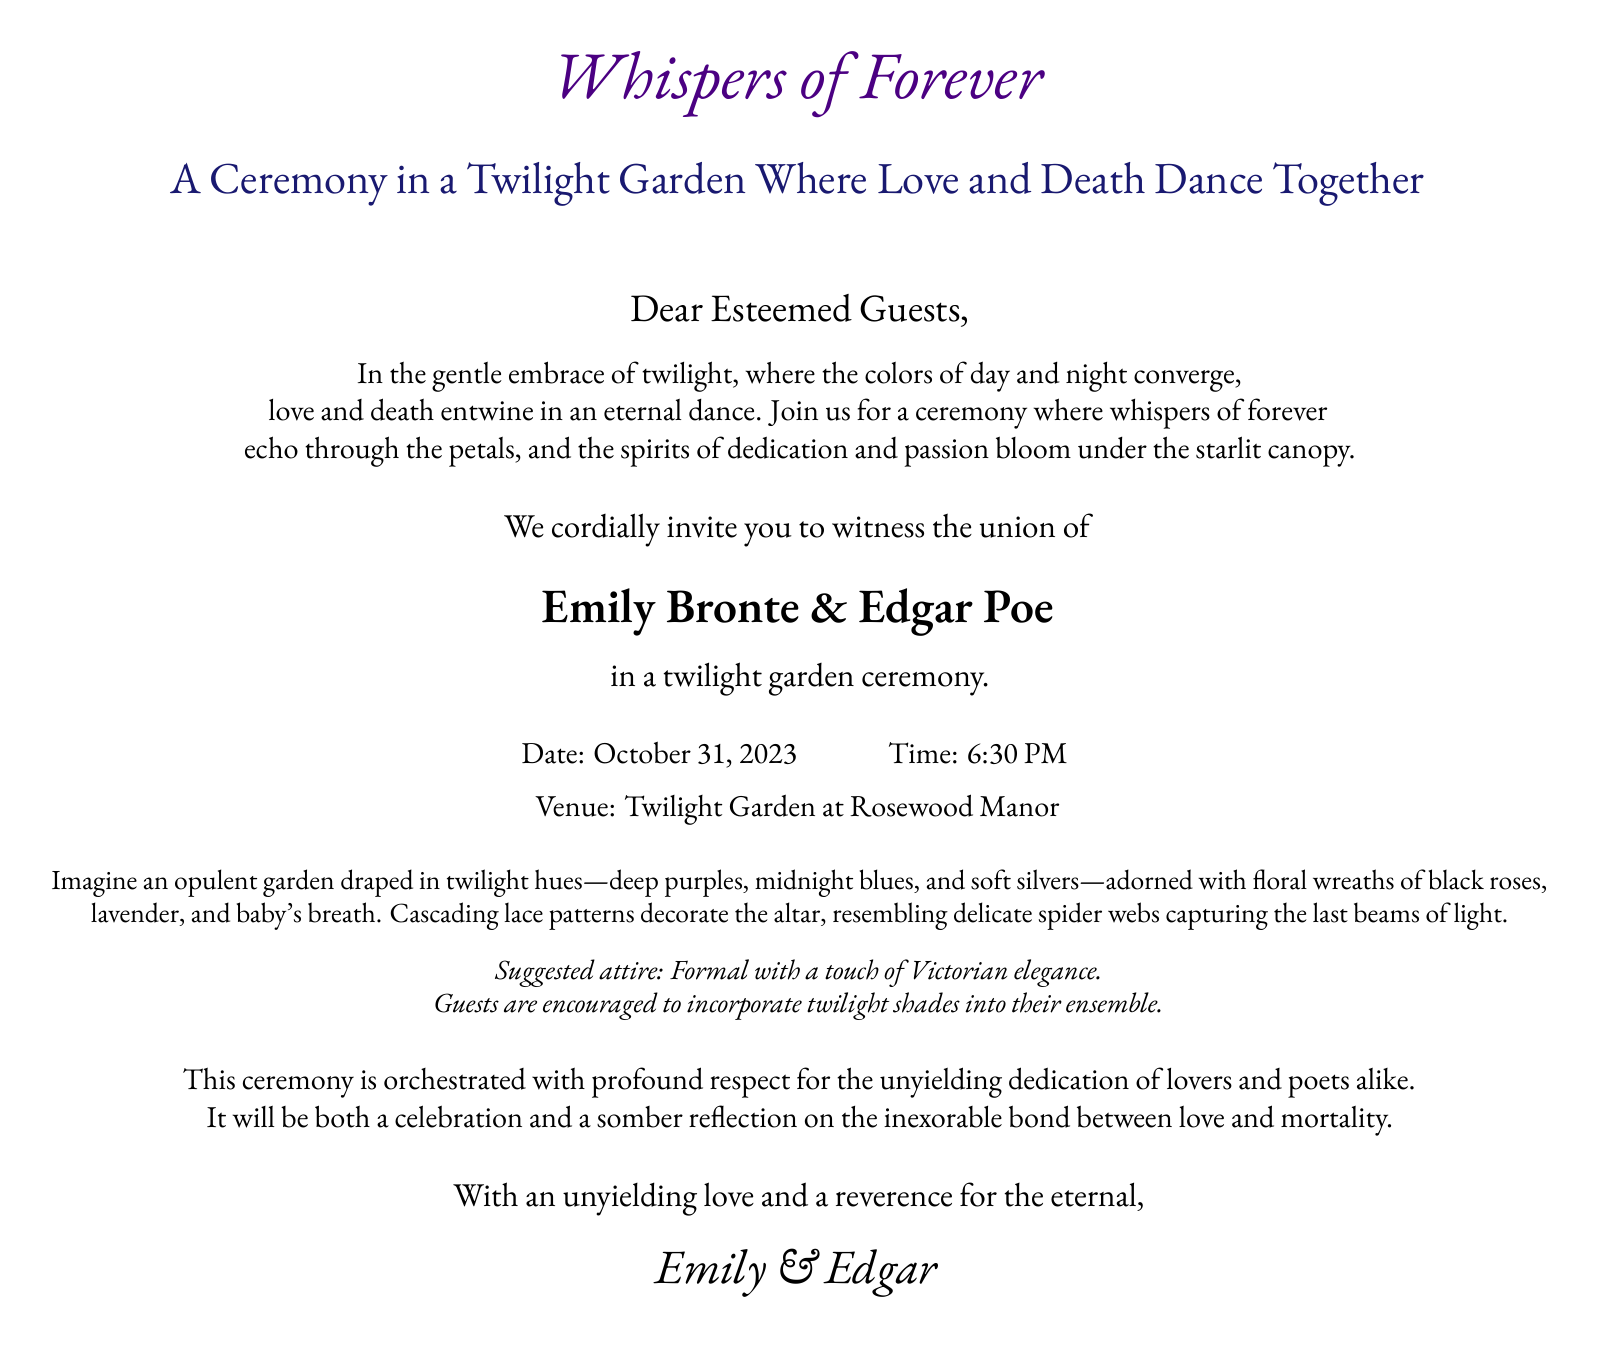What is the title of the ceremony? The title is the first line in the document which sets the theme.
Answer: Whispers of Forever Who are the couple getting married? The couple's names are highlighted in large text, indicating their importance.
Answer: Emily Bronte & Edgar Poe What is the date of the ceremony? The date is provided specifically in the invitation section.
Answer: October 31, 2023 What time does the ceremony start? The time is mentioned alongside the date in the invitation.
Answer: 6:30 PM What is the suggested attire for guests? This information is given towards the end, advising guests on how to dress.
Answer: Formal with a touch of Victorian elegance Where is the ceremony taking place? The venue is specifically stated in the invitation.
Answer: Twilight Garden at Rosewood Manor What colors are suggested for guests to incorporate into their ensemble? The invitation mentions colors in relation to twilight, which is significant for the theme.
Answer: Twilight shades What floral decorations are mentioned in the invitation? The floral elements described in detail illustrate the ceremony's ambiance.
Answer: Black roses, lavender, and baby's breath Why is this ceremony unique? The document reflects on the intertwining themes of love and death, providing depth to the occasion.
Answer: Celebration and somber reflection on love and mortality 